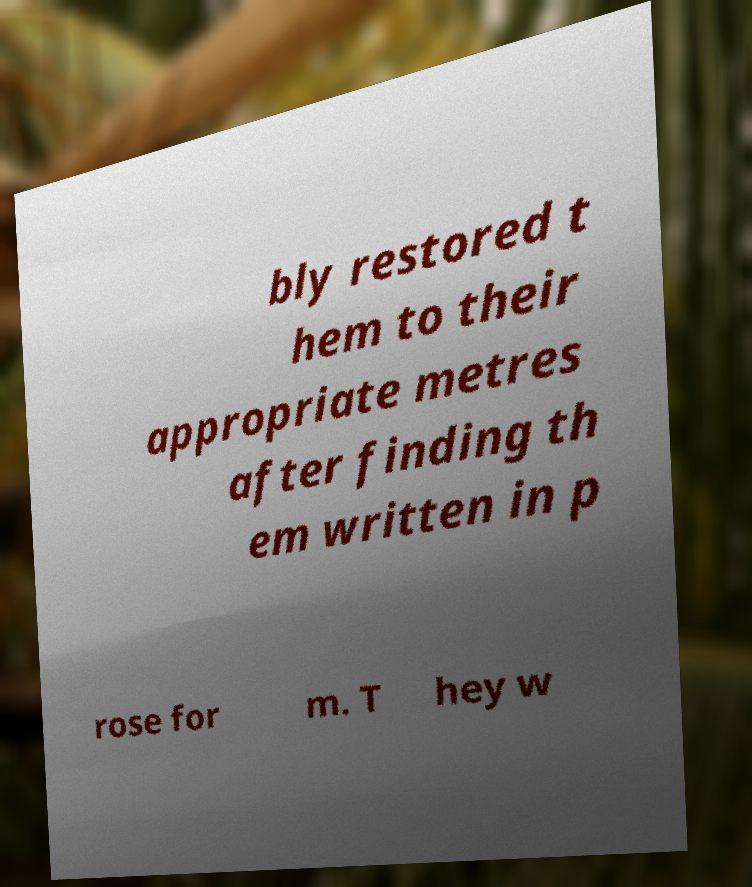I need the written content from this picture converted into text. Can you do that? bly restored t hem to their appropriate metres after finding th em written in p rose for m. T hey w 